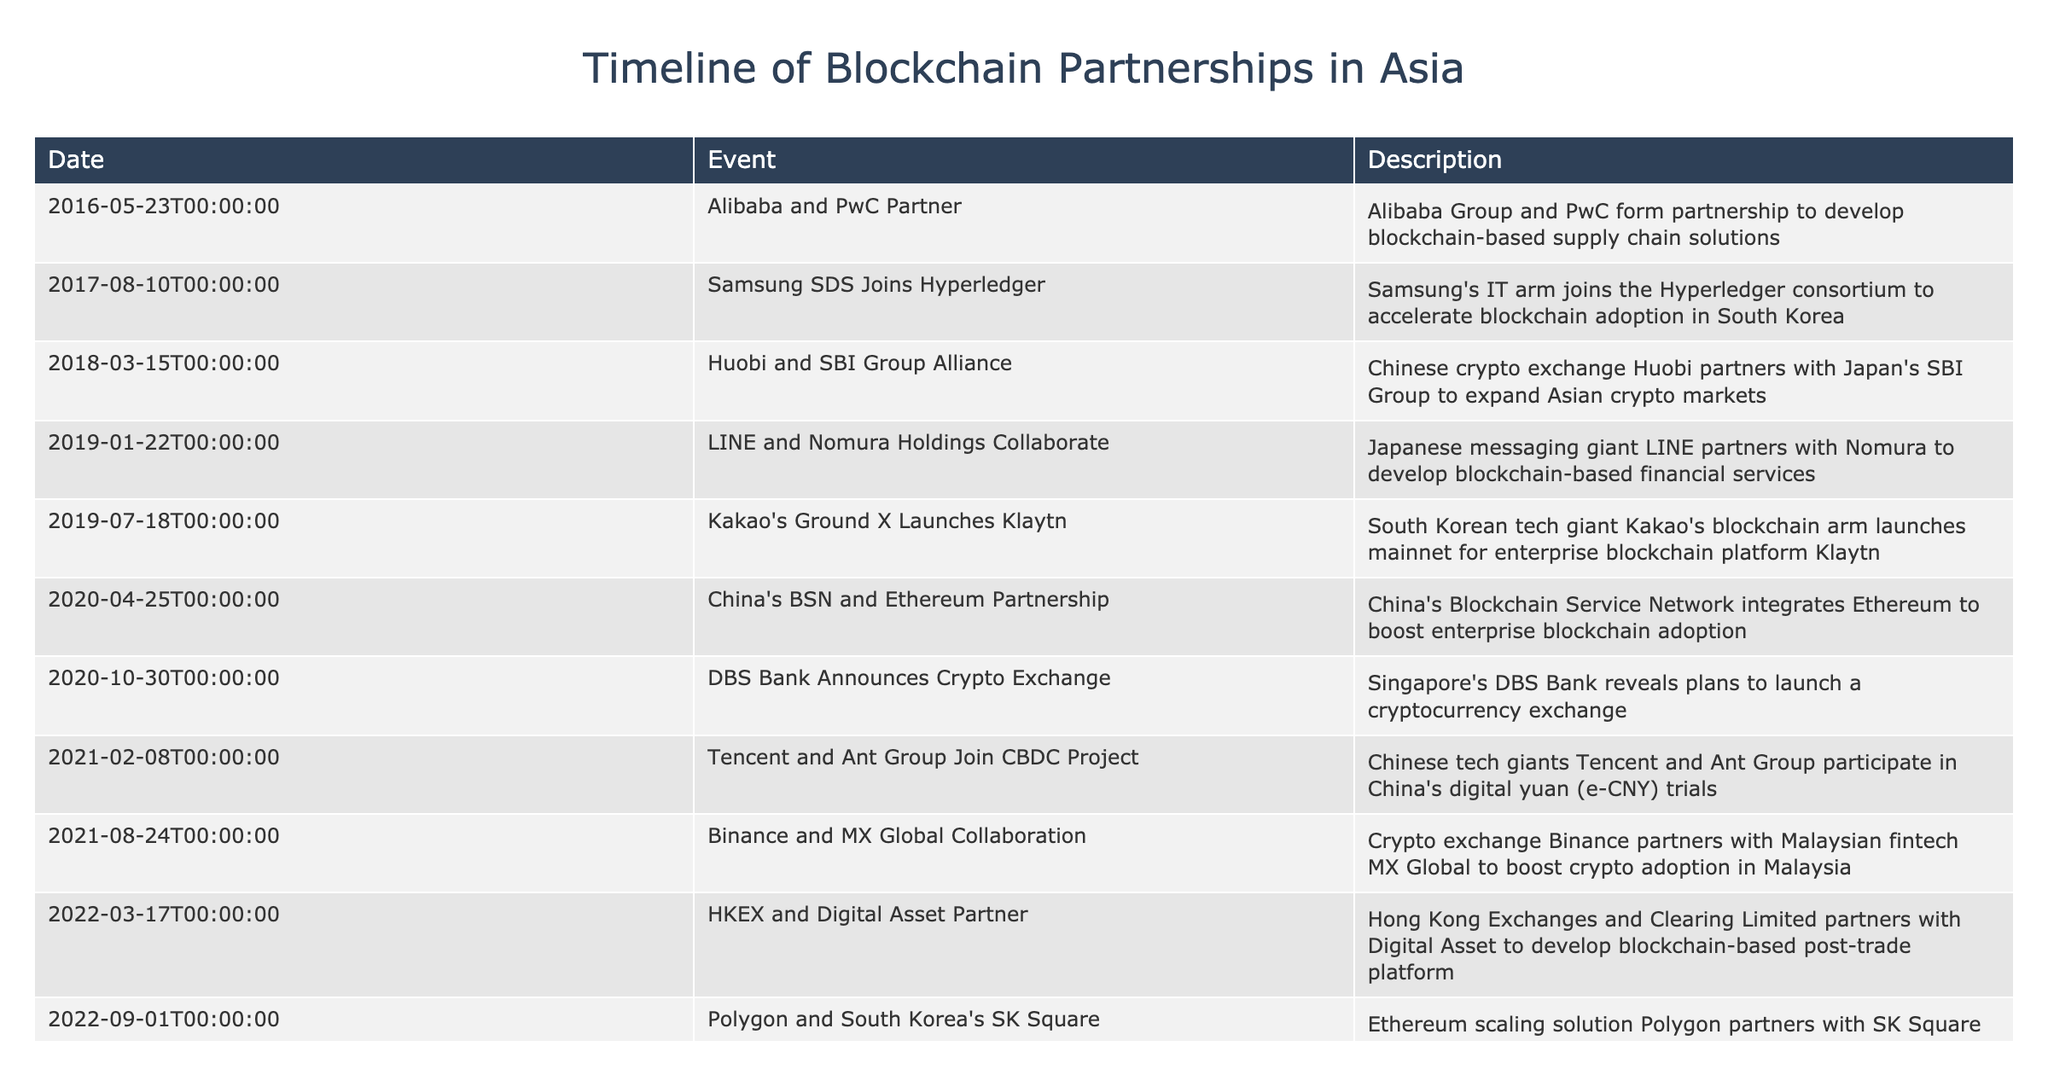What is the earliest partnership listed in the table? The table shows several partnerships with their corresponding dates. The earliest date is May 23, 2016, and the partnership is between Alibaba and PwC.
Answer: Alibaba and PwC Partner How many partnerships were formed in 2021? By checking the 'Date' column, we can see that there are three entries for the year 2021: Tencent and Ant Group, Binance and MX Global, and Huobi and SBI Group. Thus, the total is three partnerships.
Answer: 3 Did any of the partnerships occur outside of China, Japan, or South Korea? Looking through the 'Description' column, we find that the partnership between Ripple and FOMO Pay is based in Singapore. This indicates that at least one partnership has occurred outside the other two countries.
Answer: Yes Which companies collaborated to develop a blockchain-based post-trade platform? The table shows that Hong Kong Exchanges and Clearing Limited (HKEX) partnered with Digital Asset. This specific collaboration is mentioned in the 'Event' column.
Answer: HKEX and Digital Asset Which partnership aimed at cryptocurrency exchange plans? Referring to the table, we find that on October 30, 2020, DBS Bank announced plans to launch a cryptocurrency exchange.
Answer: DBS Bank Announces Crypto Exchange What is the total number of partnerships listed in the table? Counting the events listed in the table, there are a total of 13 partnerships.
Answer: 13 Which companies were involved in blockchain projects related to the digital yuan? The table notes that Tencent and Ant Group participated in China's digital yuan trials. This information is specifically mentioned in the description for the event dated February 8, 2021.
Answer: Tencent and Ant Group In which year did the partnership between Polygon and SK Square occur? From the 'Date' column, we can identify that the partnership between Polygon and SK Square took place on September 1, 2022. Thus, the year is 2022.
Answer: 2022 List the companies involved in the partnership to integrate Ethereum. The table shows that China's Blockchain Service Network (BSN) integrated with Ethereum, as mentioned in the description for the event dated April 25, 2020.
Answer: China's BSN and Ethereum 